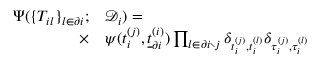<formula> <loc_0><loc_0><loc_500><loc_500>\begin{array} { r } { \begin{array} { r l } { \Psi ( \{ T _ { i l } \} _ { l \in \partial i } ; } & \mathcal { D } _ { i } ) = } \\ { \times } & \psi ( t _ { i } ^ { ( j ) } , \underline { t } _ { \partial i } ^ { ( i ) } ) \prod _ { l \in \partial i \ j } \delta _ { t _ { i } ^ { ( j ) } , t _ { i } ^ { ( l ) } } \delta _ { \tau _ { i } ^ { ( j ) } , \tau _ { i } ^ { ( l ) } } } \end{array} } \end{array}</formula> 